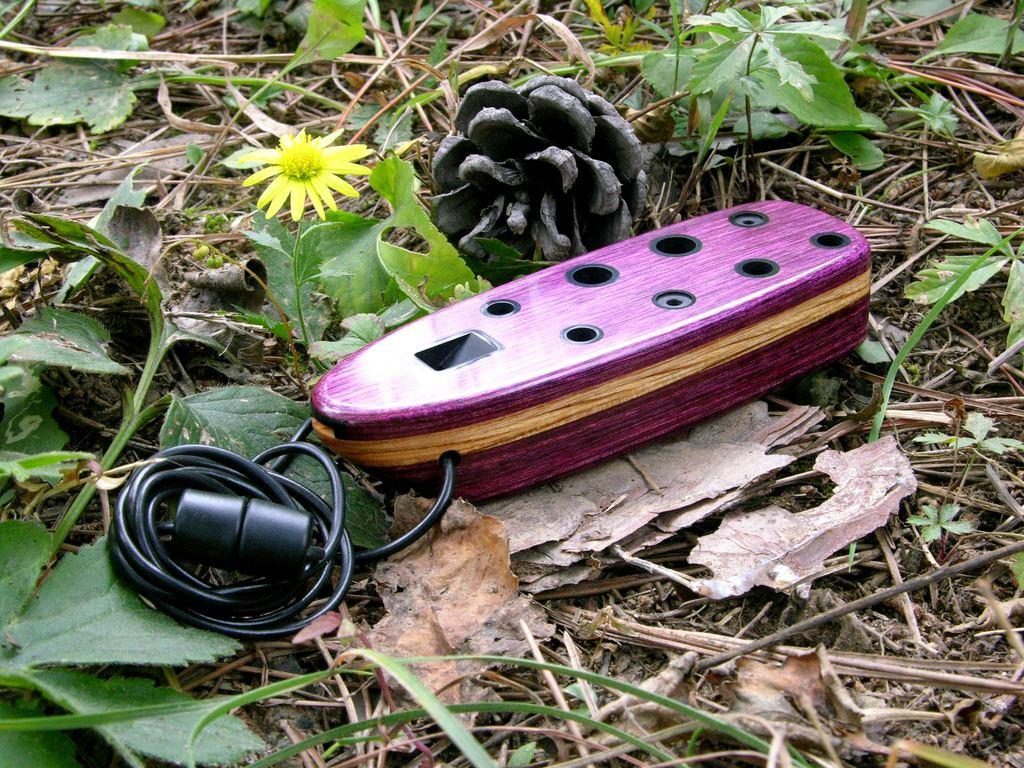What is placed on the ground in the image? There is a box placed on the ground in the image. What type of vegetation can be seen in the image? Plants are visible in the image. What else can be found on the ground in the image? Dry leaves are present in the image. What type of soap is being used to clean the cars in the image? There are no cars or soap present in the image; it only features a box, plants, and dry leaves. 